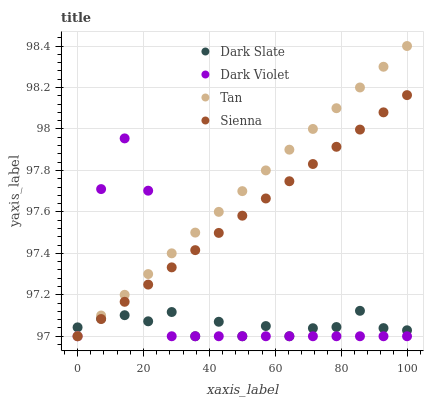Does Dark Slate have the minimum area under the curve?
Answer yes or no. Yes. Does Tan have the maximum area under the curve?
Answer yes or no. Yes. Does Tan have the minimum area under the curve?
Answer yes or no. No. Does Dark Slate have the maximum area under the curve?
Answer yes or no. No. Is Sienna the smoothest?
Answer yes or no. Yes. Is Dark Violet the roughest?
Answer yes or no. Yes. Is Dark Slate the smoothest?
Answer yes or no. No. Is Dark Slate the roughest?
Answer yes or no. No. Does Sienna have the lowest value?
Answer yes or no. Yes. Does Tan have the highest value?
Answer yes or no. Yes. Does Dark Slate have the highest value?
Answer yes or no. No. Does Dark Slate intersect Dark Violet?
Answer yes or no. Yes. Is Dark Slate less than Dark Violet?
Answer yes or no. No. Is Dark Slate greater than Dark Violet?
Answer yes or no. No. 